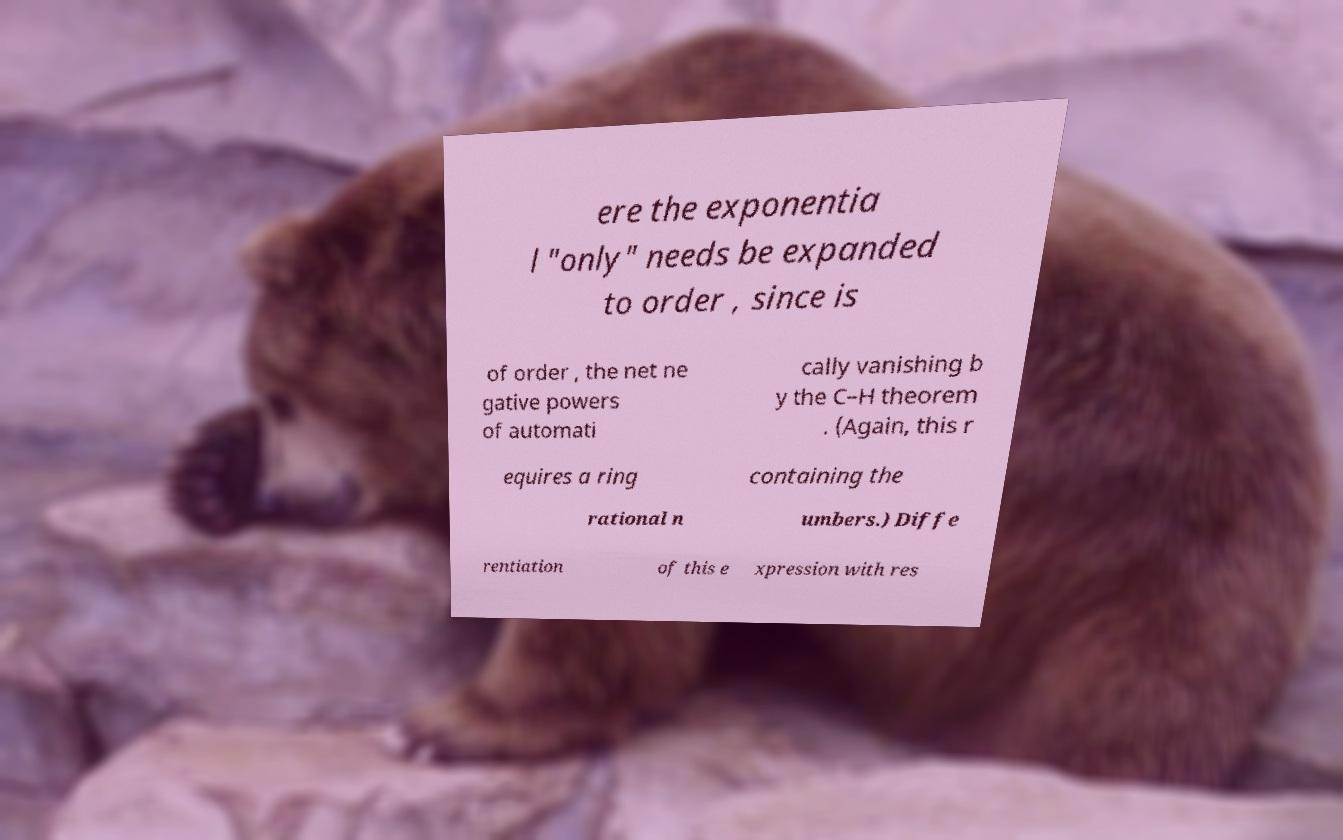For documentation purposes, I need the text within this image transcribed. Could you provide that? ere the exponentia l "only" needs be expanded to order , since is of order , the net ne gative powers of automati cally vanishing b y the C–H theorem . (Again, this r equires a ring containing the rational n umbers.) Diffe rentiation of this e xpression with res 